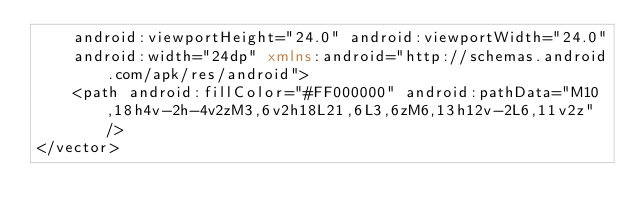Convert code to text. <code><loc_0><loc_0><loc_500><loc_500><_XML_>    android:viewportHeight="24.0" android:viewportWidth="24.0"
    android:width="24dp" xmlns:android="http://schemas.android.com/apk/res/android">
    <path android:fillColor="#FF000000" android:pathData="M10,18h4v-2h-4v2zM3,6v2h18L21,6L3,6zM6,13h12v-2L6,11v2z"/>
</vector>
</code> 